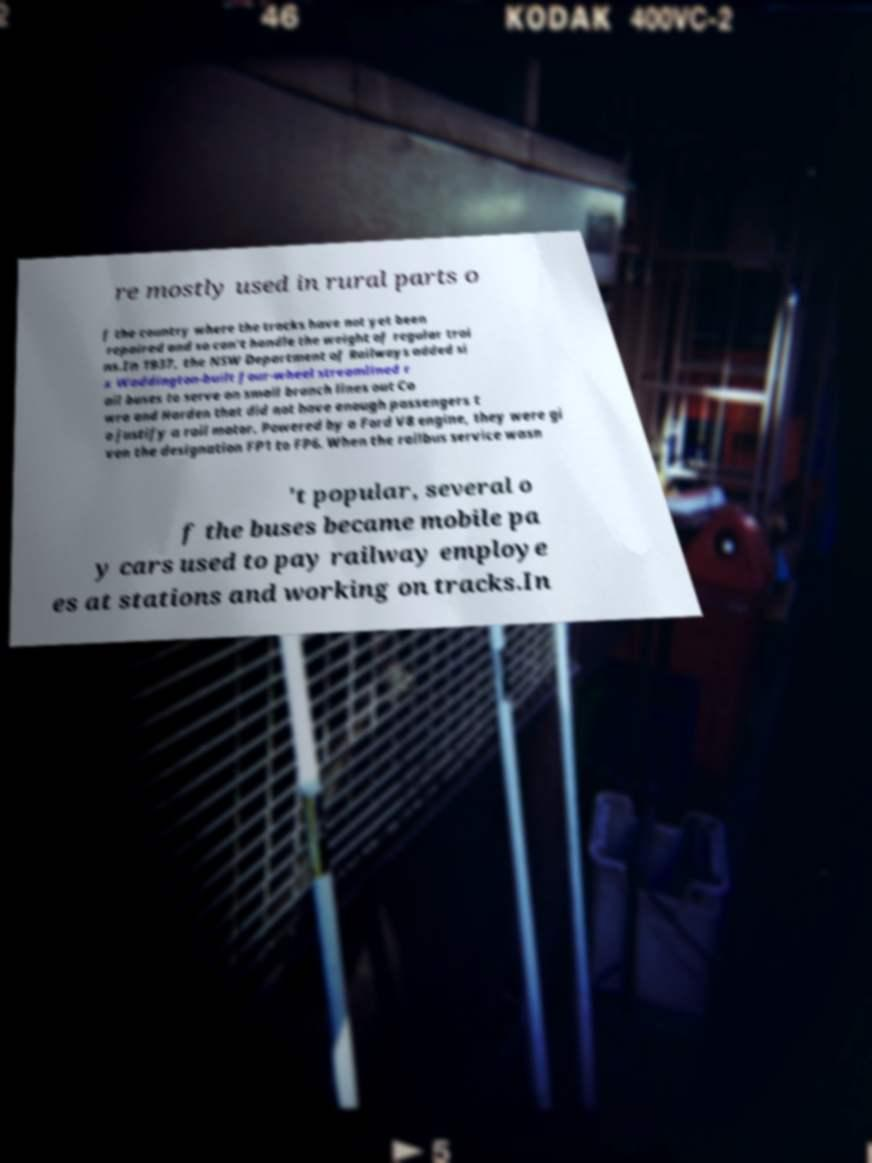Could you extract and type out the text from this image? re mostly used in rural parts o f the country where the tracks have not yet been repaired and so can't handle the weight of regular trai ns.In 1937, the NSW Department of Railways added si x Waddington-built four-wheel streamlined r ail buses to serve on small branch lines out Co wra and Harden that did not have enough passengers t o justify a rail motor. Powered by a Ford V8 engine, they were gi ven the designation FP1 to FP6. When the railbus service wasn 't popular, several o f the buses became mobile pa y cars used to pay railway employe es at stations and working on tracks.In 